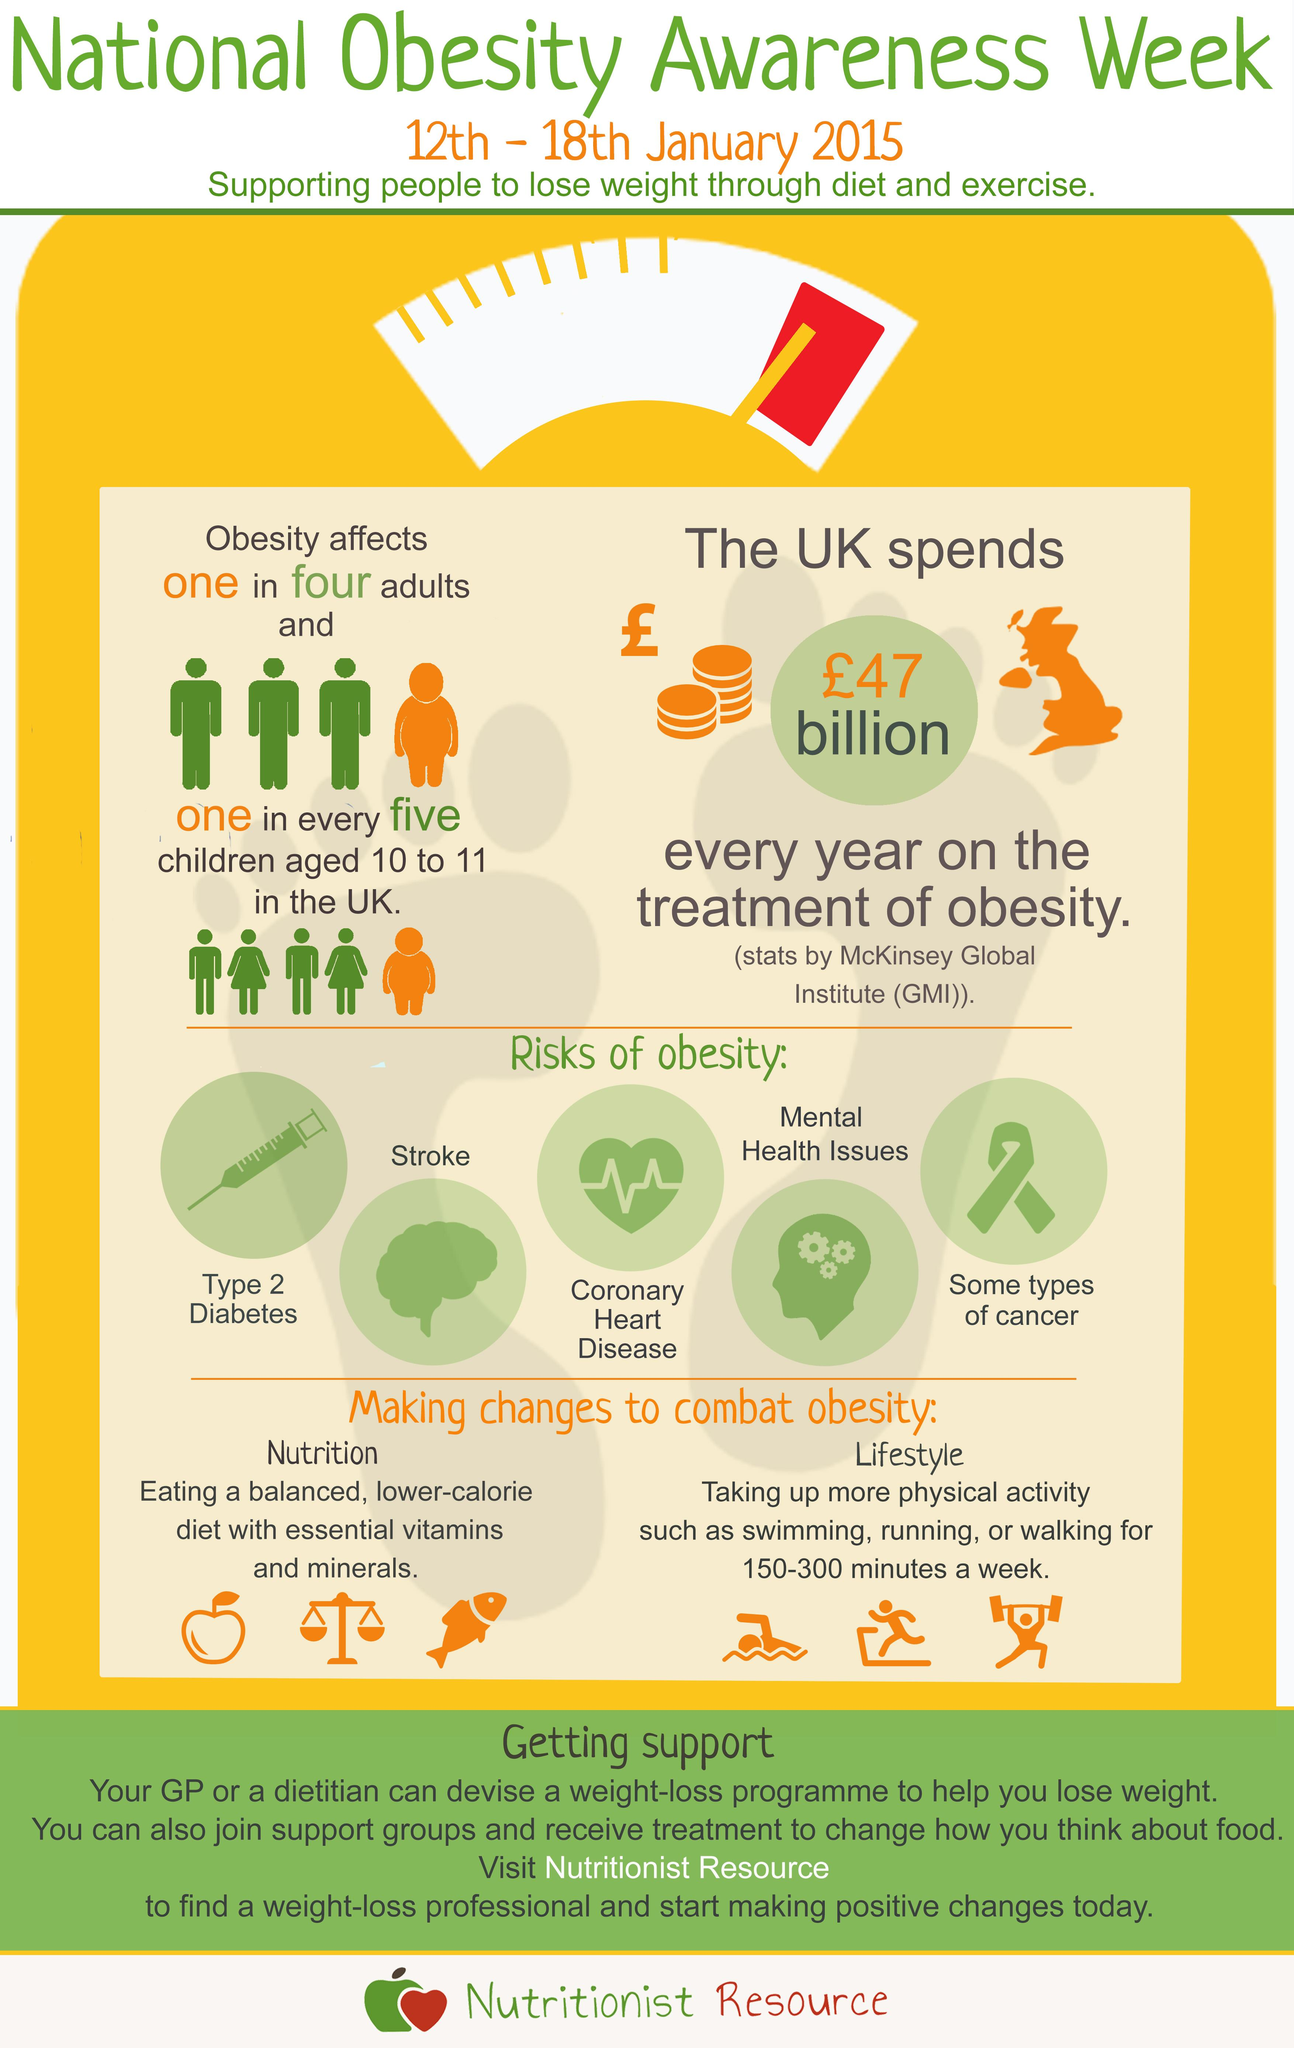Give some essential details in this illustration. The image of a syringe represents the possibility of developing type 2 diabetes, stroke, or cancer. A balanced low calorie diet that combats obesity should include essential vitamins and minerals to ensure overall health and well-being. Obesity is a common lifestyle disease affecting one in five children in the UK. Swimming, running, and walking are physical activities that should be included to prevent obesity. Coronary heart disease is represented by the image of a heart. 